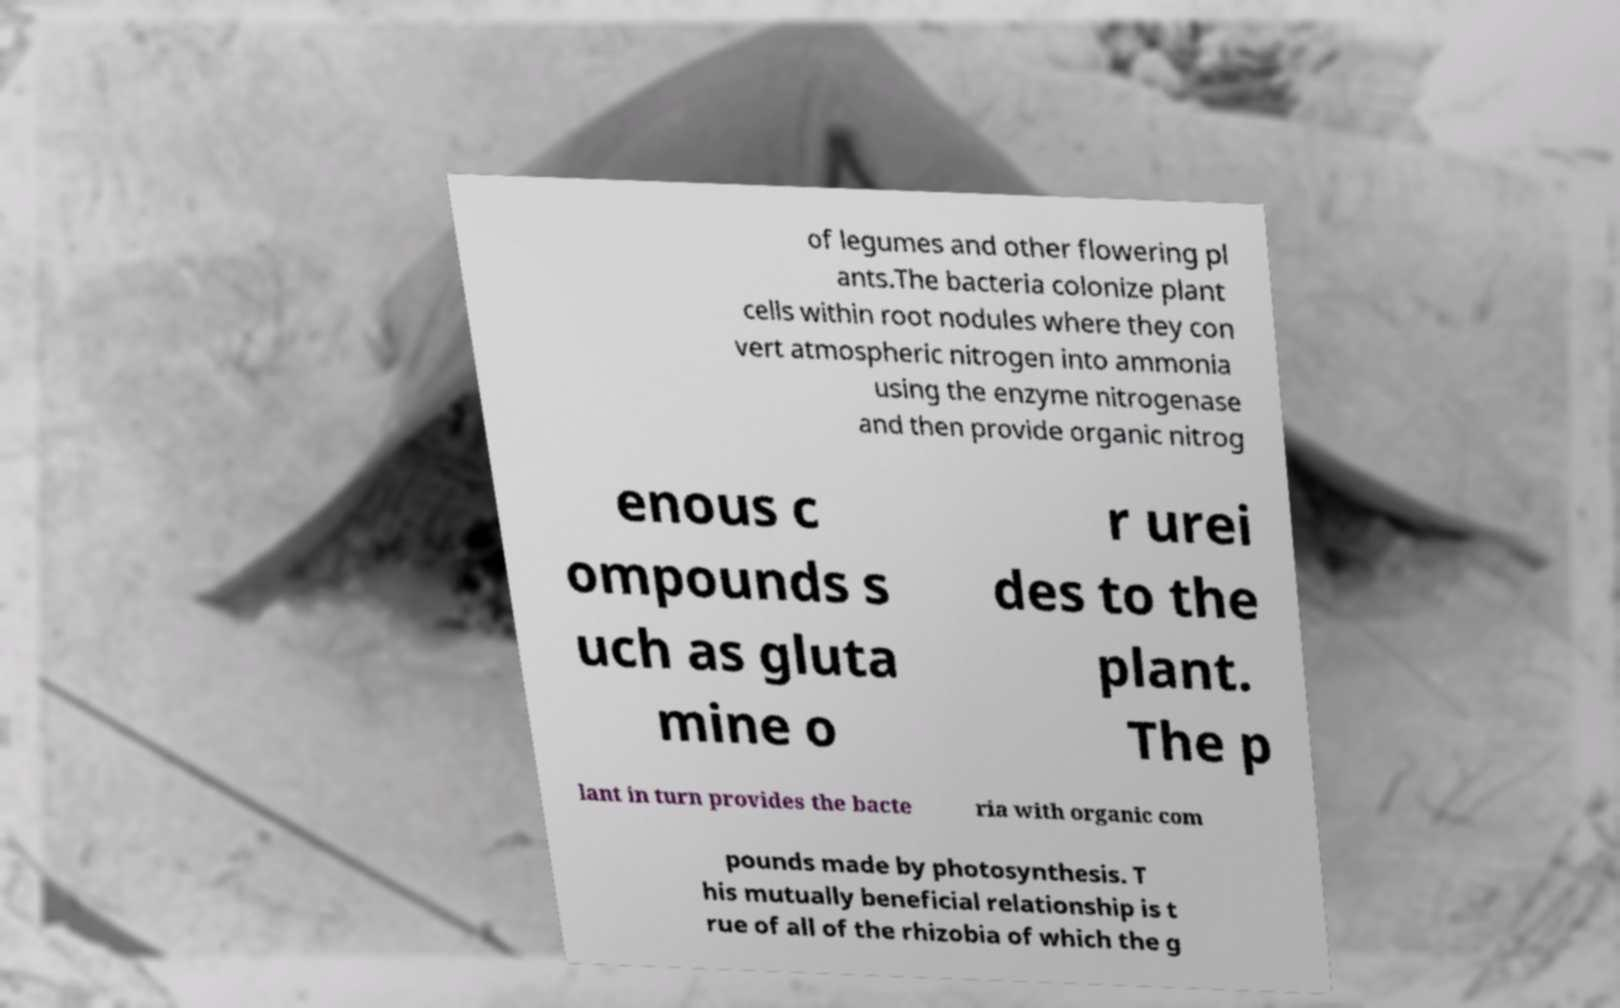There's text embedded in this image that I need extracted. Can you transcribe it verbatim? of legumes and other flowering pl ants.The bacteria colonize plant cells within root nodules where they con vert atmospheric nitrogen into ammonia using the enzyme nitrogenase and then provide organic nitrog enous c ompounds s uch as gluta mine o r urei des to the plant. The p lant in turn provides the bacte ria with organic com pounds made by photosynthesis. T his mutually beneficial relationship is t rue of all of the rhizobia of which the g 